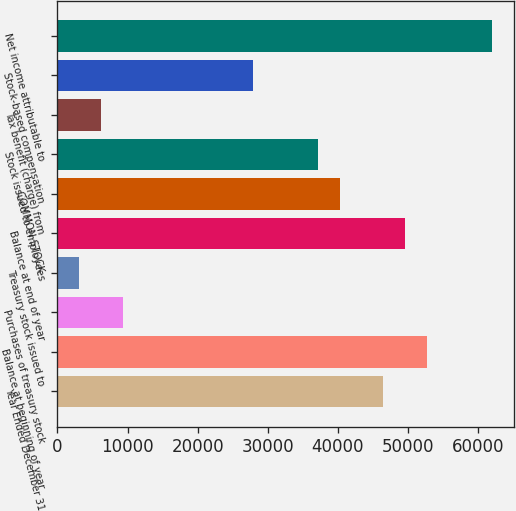Convert chart to OTSL. <chart><loc_0><loc_0><loc_500><loc_500><bar_chart><fcel>Year Ended December 31<fcel>Balance at beginning of year<fcel>Purchases of treasury stock<fcel>Treasury stock issued to<fcel>Balance at end of year<fcel>COMMON STOCK<fcel>Stock issued to employees<fcel>Tax benefit (charge) from<fcel>Stock-based compensation<fcel>Net income attributable to<nl><fcel>46488.5<fcel>52682.7<fcel>9323.3<fcel>3129.1<fcel>49585.6<fcel>40294.3<fcel>37197.2<fcel>6226.2<fcel>27905.9<fcel>61974<nl></chart> 